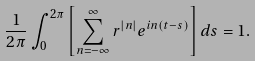Convert formula to latex. <formula><loc_0><loc_0><loc_500><loc_500>\frac { 1 } { 2 \pi } \int _ { 0 } ^ { 2 \pi } \left [ \sum _ { n = - \infty } ^ { \infty } r ^ { | n | } e ^ { i n ( t - s ) } \right ] d s = 1 .</formula> 